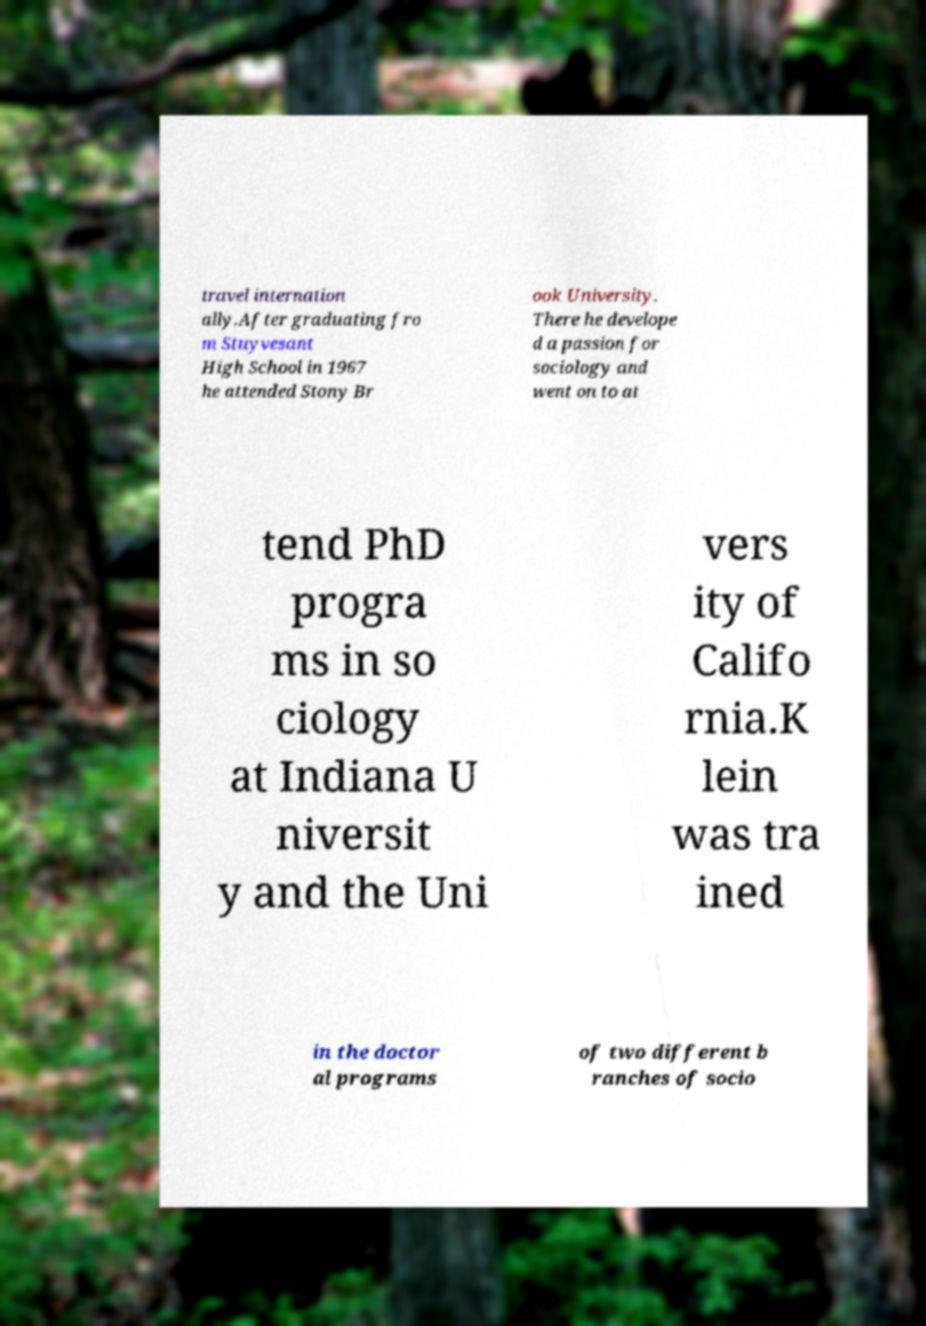Can you read and provide the text displayed in the image?This photo seems to have some interesting text. Can you extract and type it out for me? travel internation ally.After graduating fro m Stuyvesant High School in 1967 he attended Stony Br ook University. There he develope d a passion for sociology and went on to at tend PhD progra ms in so ciology at Indiana U niversit y and the Uni vers ity of Califo rnia.K lein was tra ined in the doctor al programs of two different b ranches of socio 